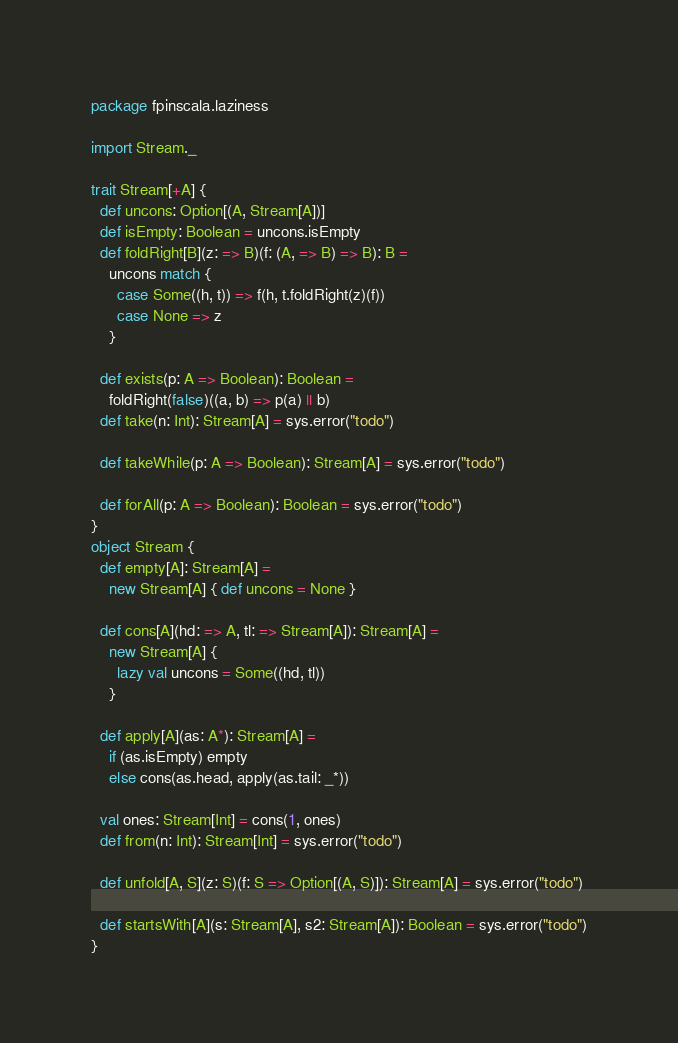Convert code to text. <code><loc_0><loc_0><loc_500><loc_500><_Scala_>package fpinscala.laziness

import Stream._

trait Stream[+A] {
  def uncons: Option[(A, Stream[A])]
  def isEmpty: Boolean = uncons.isEmpty
  def foldRight[B](z: => B)(f: (A, => B) => B): B =
    uncons match {
      case Some((h, t)) => f(h, t.foldRight(z)(f))
      case None => z
    }

  def exists(p: A => Boolean): Boolean = 
    foldRight(false)((a, b) => p(a) || b)
  def take(n: Int): Stream[A] = sys.error("todo")

  def takeWhile(p: A => Boolean): Stream[A] = sys.error("todo")

  def forAll(p: A => Boolean): Boolean = sys.error("todo")
}
object Stream {
  def empty[A]: Stream[A] = 
    new Stream[A] { def uncons = None }
  
  def cons[A](hd: => A, tl: => Stream[A]): Stream[A] = 
    new Stream[A] {
      lazy val uncons = Some((hd, tl)) 
    }
  
  def apply[A](as: A*): Stream[A] =
    if (as.isEmpty) empty
    else cons(as.head, apply(as.tail: _*))

  val ones: Stream[Int] = cons(1, ones)
  def from(n: Int): Stream[Int] = sys.error("todo")

  def unfold[A, S](z: S)(f: S => Option[(A, S)]): Stream[A] = sys.error("todo")

  def startsWith[A](s: Stream[A], s2: Stream[A]): Boolean = sys.error("todo")
}</code> 